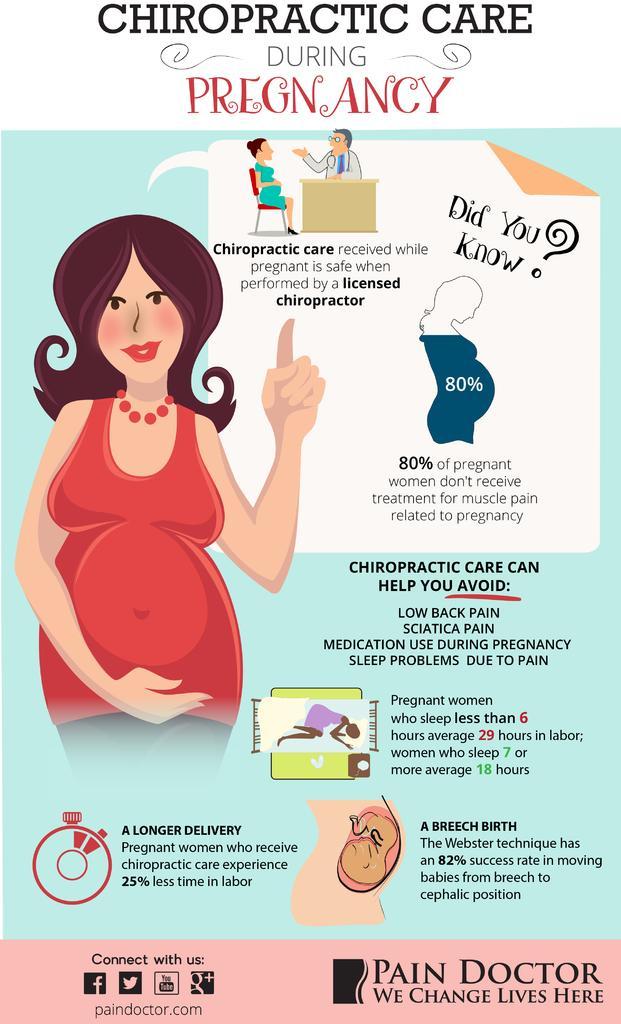What is present in the image that contains both images and text? There is a poster in the image that contains images and text. What type of credit can be seen on the poster in the image? There is no credit mentioned or visible on the poster in the image. What kind of protest is depicted in the images on the poster? There are no images of protests on the poster in the image. 